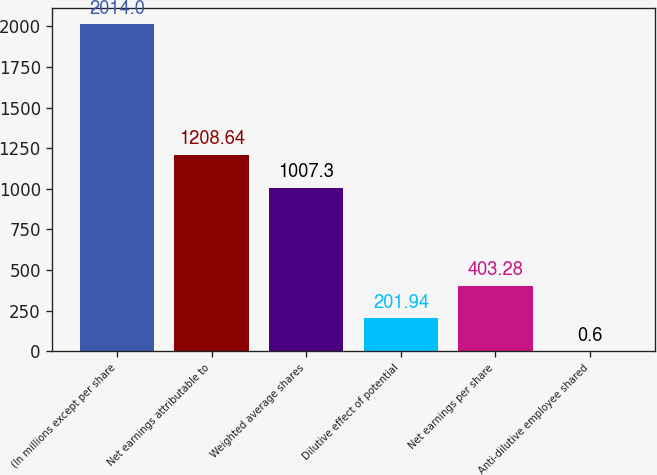Convert chart to OTSL. <chart><loc_0><loc_0><loc_500><loc_500><bar_chart><fcel>(In millions except per share<fcel>Net earnings attributable to<fcel>Weighted average shares<fcel>Dilutive effect of potential<fcel>Net earnings per share<fcel>Anti-dilutive employee shared<nl><fcel>2014<fcel>1208.64<fcel>1007.3<fcel>201.94<fcel>403.28<fcel>0.6<nl></chart> 